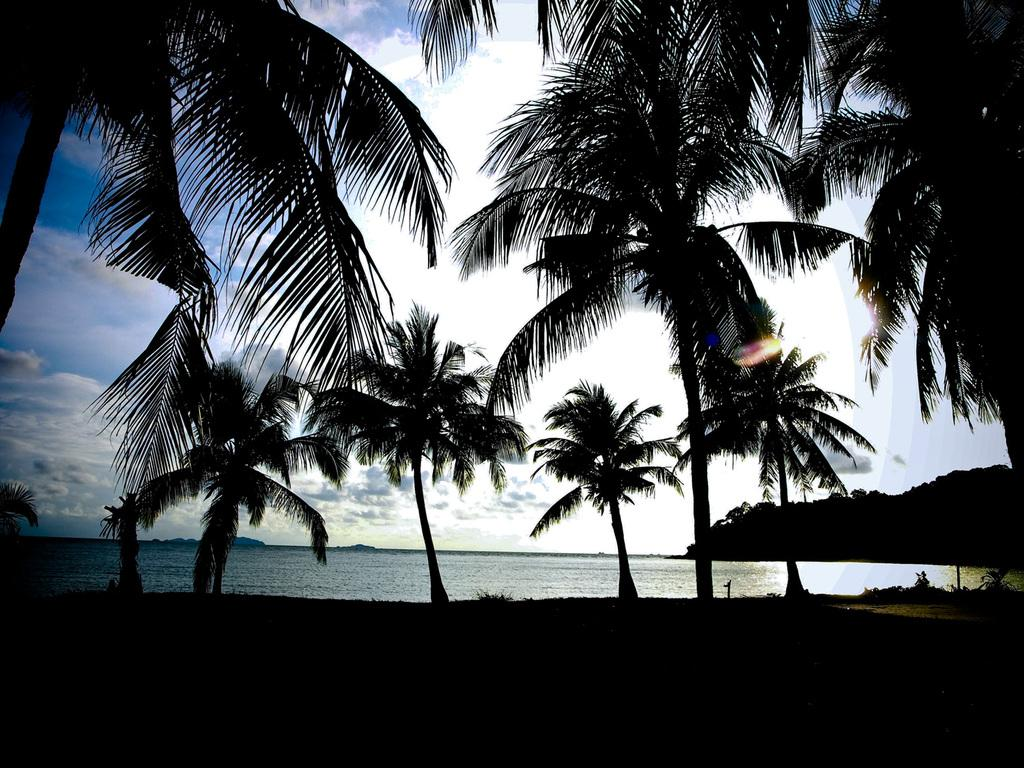What type of natural environment can be seen in the background of the image? There are trees and water visible in the background of the image. Can you describe the setting in which the image was taken? The image appears to have been taken in a natural environment, possibly near a body of water with trees in the background. What color is the chalk used to draw on the fifth tree in the image? There is no chalk or drawing present in the image, and there is no mention of a fifth tree. 